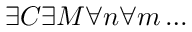<formula> <loc_0><loc_0><loc_500><loc_500>\exists C \exists M \forall n \forall m \dots</formula> 